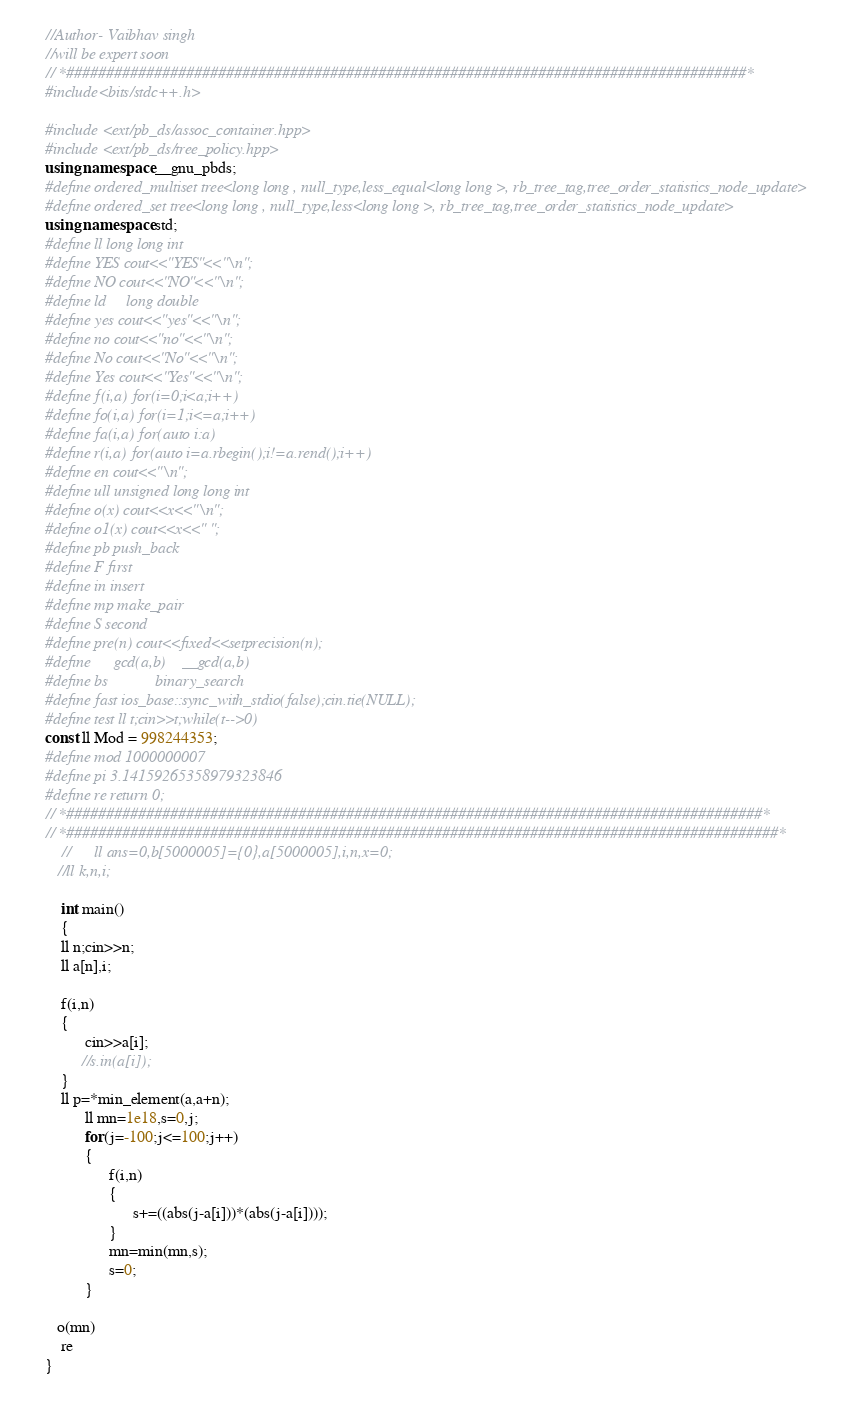Convert code to text. <code><loc_0><loc_0><loc_500><loc_500><_C++_>//Author- Vaibhav singh
//will be expert soon 
// *#####################################################################################*
#include<bits/stdc++.h>

#include <ext/pb_ds/assoc_container.hpp>
#include <ext/pb_ds/tree_policy.hpp>
using namespace __gnu_pbds;
#define ordered_multiset tree<long long , null_type,less_equal<long long >, rb_tree_tag,tree_order_statistics_node_update>
#define ordered_set tree<long long , null_type,less<long long >, rb_tree_tag,tree_order_statistics_node_update>
using namespace std;
#define ll long long int
#define YES cout<<"YES"<<"\n";
#define NO cout<<"NO"<<"\n";
#define ld     long double
#define yes cout<<"yes"<<"\n";
#define no cout<<"no"<<"\n";
#define No cout<<"No"<<"\n";
#define Yes cout<<"Yes"<<"\n";
#define f(i,a) for(i=0;i<a;i++)
#define fo(i,a) for(i=1;i<=a;i++)
#define fa(i,a) for(auto i:a)
#define r(i,a) for(auto i=a.rbegin();i!=a.rend();i++)
#define en cout<<"\n";
#define ull unsigned long long int
#define o(x) cout<<x<<"\n";
#define o1(x) cout<<x<<" ";
#define pb push_back
#define F first
#define in insert
#define mp make_pair
#define S second
#define pre(n) cout<<fixed<<setprecision(n);
#define      gcd(a,b)    __gcd(a,b)
#define bs            binary_search
#define fast ios_base::sync_with_stdio(false);cin.tie(NULL);
#define test ll t;cin>>t;while(t-->0)
const ll Mod = 998244353;
#define mod 1000000007
#define pi 3.14159265358979323846
#define re return 0;
// *#######################################################################################*
// *#########################################################################################*
    //      ll ans=0,b[5000005]={0},a[5000005],i,n,x=0;                
   //ll k,n,i;

    int main()
    {
    ll n;cin>>n;
    ll a[n],i;
    
    f(i,n)
    {
          cin>>a[i];
         //s.in(a[i]);          
    }
    ll p=*min_element(a,a+n);
          ll mn=1e18,s=0,j;
          for(j=-100;j<=100;j++)
          {
                f(i,n)
                {
                      s+=((abs(j-a[i]))*(abs(j-a[i])));
                }
                mn=min(mn,s);
                s=0;
          }
          
   o(mn)
    re
}</code> 